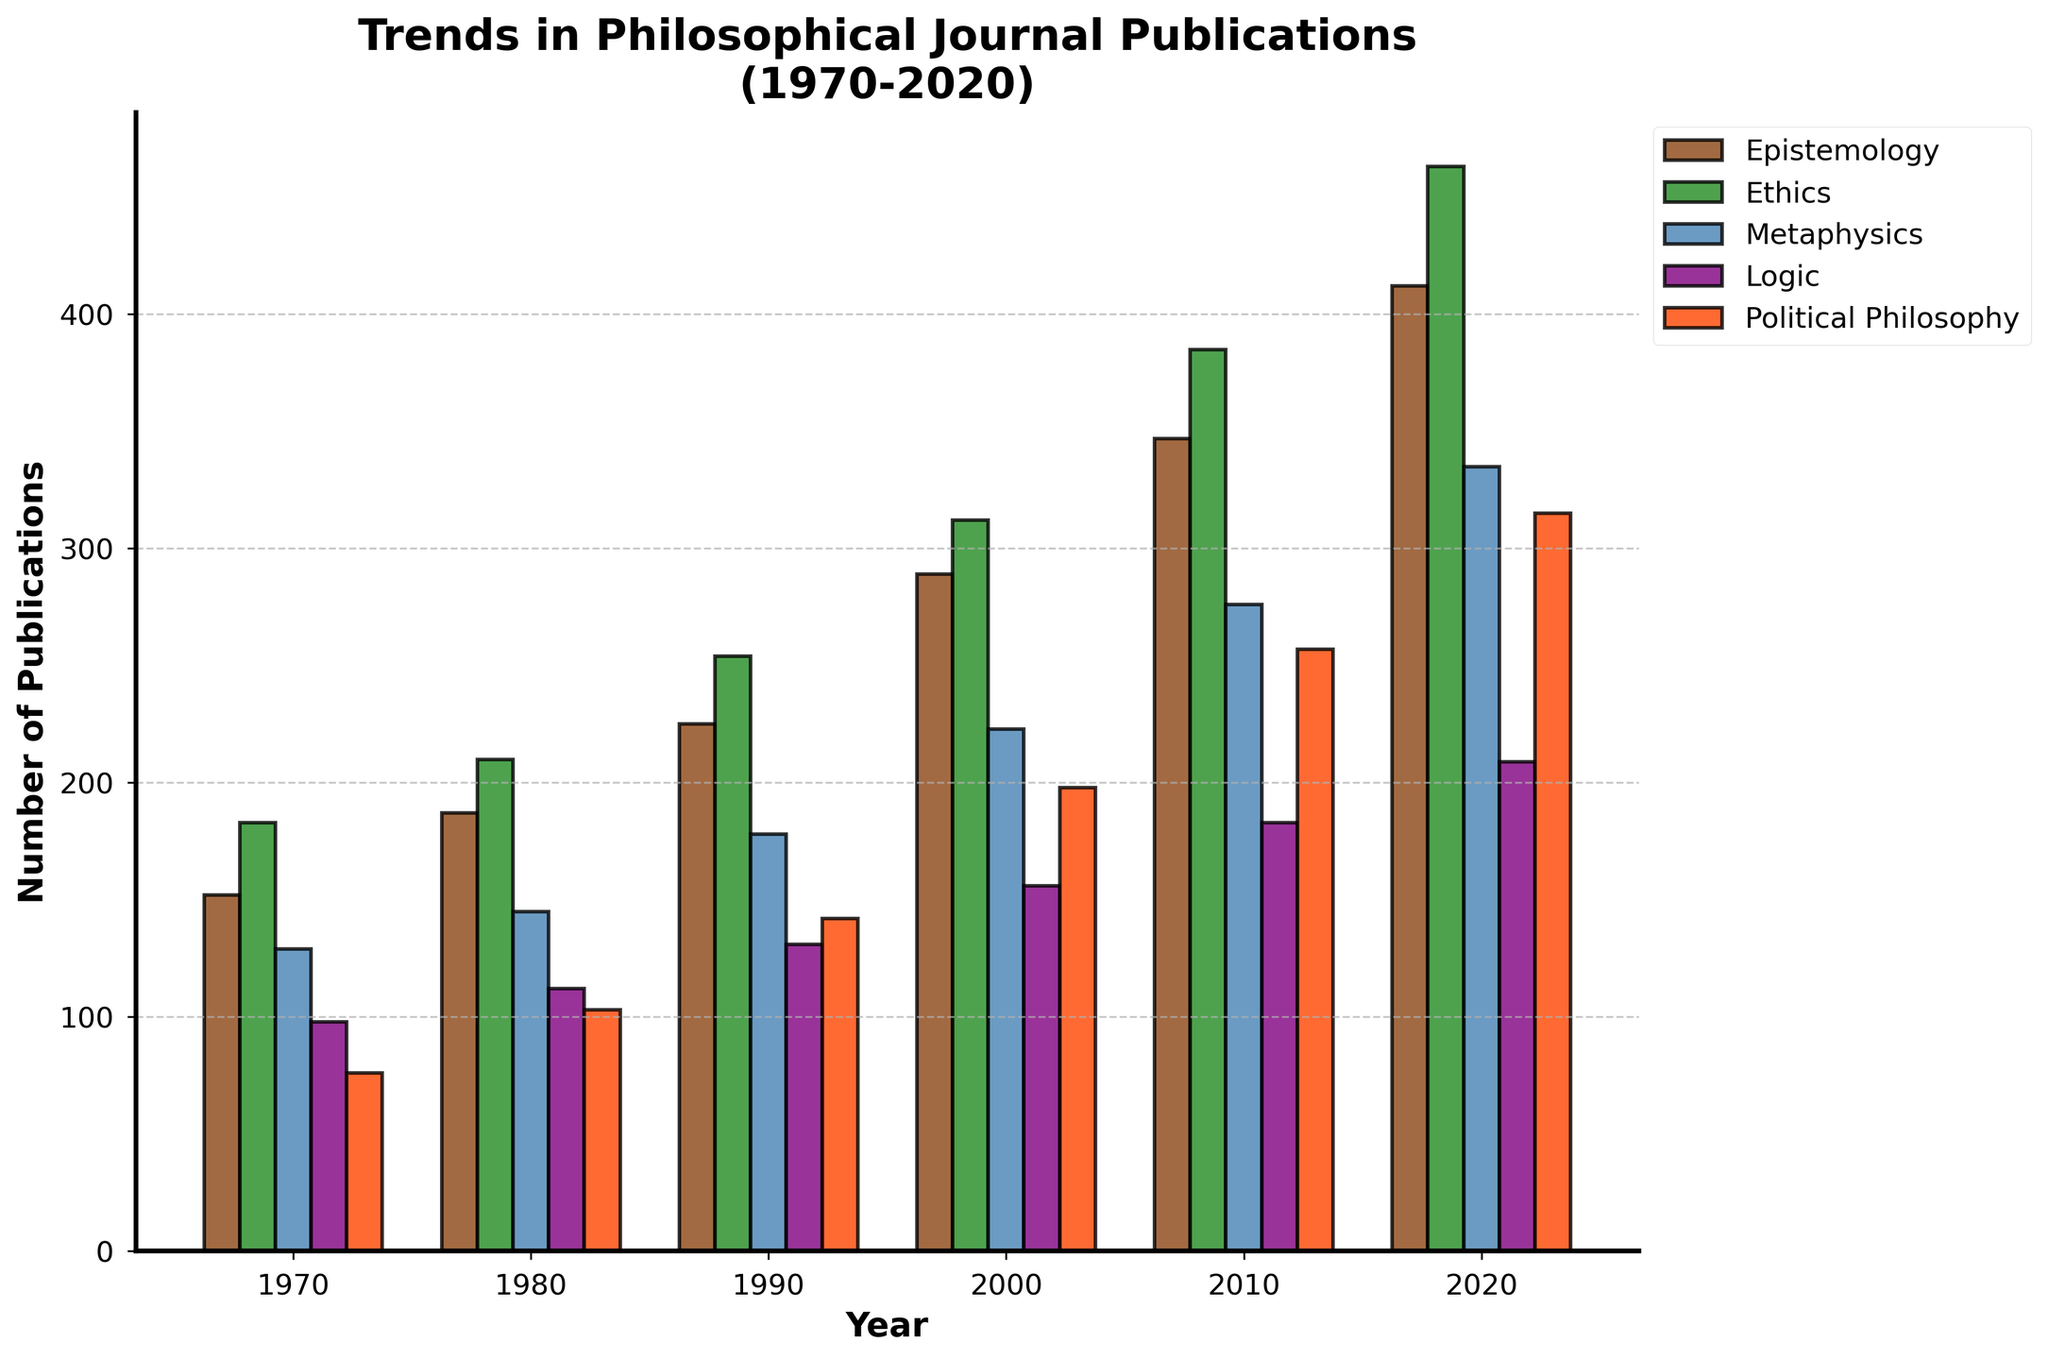Which year had the highest number of publications in Political Philosophy? Evaluating the bar heights in the "Political Philosophy" category, the highest publication count occurred in 2020 with a bar significantly taller than the previous years.
Answer: 2020 What is the average number of publications in Logic from 1970 to 2020? Add the publication numbers for Logic across all years and divide by the number of years: (98 + 112 + 131 + 156 + 183 + 209) / 6 = 889 / 6 ≈ 148.17
Answer: Approximately 148.17 Which two fields had an equal number of publications in the same year, and what was that publication number? Checking the bars, in 2000, Metaphysics and Logic both had the same bar height corresponding to 223 publications.
Answer: Metaphysics and Logic had 223 publications in 2000 How many more publications were there in Ethics compared to Metaphysics in 1990? Subtract the number of publications in Metaphysics from Ethics for 1990: 254 - 178 = 76
Answer: 76 Between 1970 and 2020, which field had the least growth in publication numbers? Comparing the total increases for each field calculated as: Epistemology (260), Ethics (280), Metaphysics (206), Logic (111), Political Philosophy (239), Logic had the smallest increase.
Answer: Logic Describe the visual pattern for the trend in Epistemology publications over time. Observing the bar heights for Epistemology, there is a consistent and steady growth across each decade.
Answer: Steady growth What is the combined total of publications in Logic and Political Philosophy in 2020? Add the publication numbers for Logic and Political Philosophy in 2020: 209 (Logic) + 315 (Political Philosophy) = 524
Answer: 524 